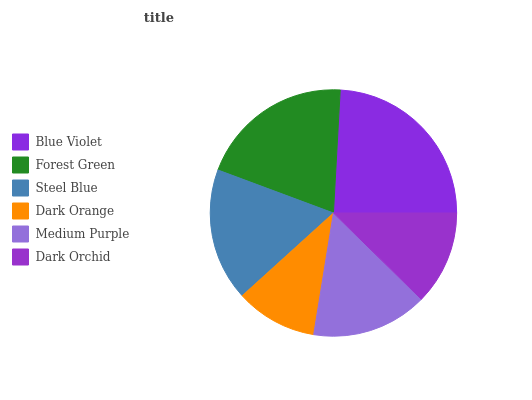Is Dark Orange the minimum?
Answer yes or no. Yes. Is Blue Violet the maximum?
Answer yes or no. Yes. Is Forest Green the minimum?
Answer yes or no. No. Is Forest Green the maximum?
Answer yes or no. No. Is Blue Violet greater than Forest Green?
Answer yes or no. Yes. Is Forest Green less than Blue Violet?
Answer yes or no. Yes. Is Forest Green greater than Blue Violet?
Answer yes or no. No. Is Blue Violet less than Forest Green?
Answer yes or no. No. Is Steel Blue the high median?
Answer yes or no. Yes. Is Medium Purple the low median?
Answer yes or no. Yes. Is Dark Orange the high median?
Answer yes or no. No. Is Forest Green the low median?
Answer yes or no. No. 